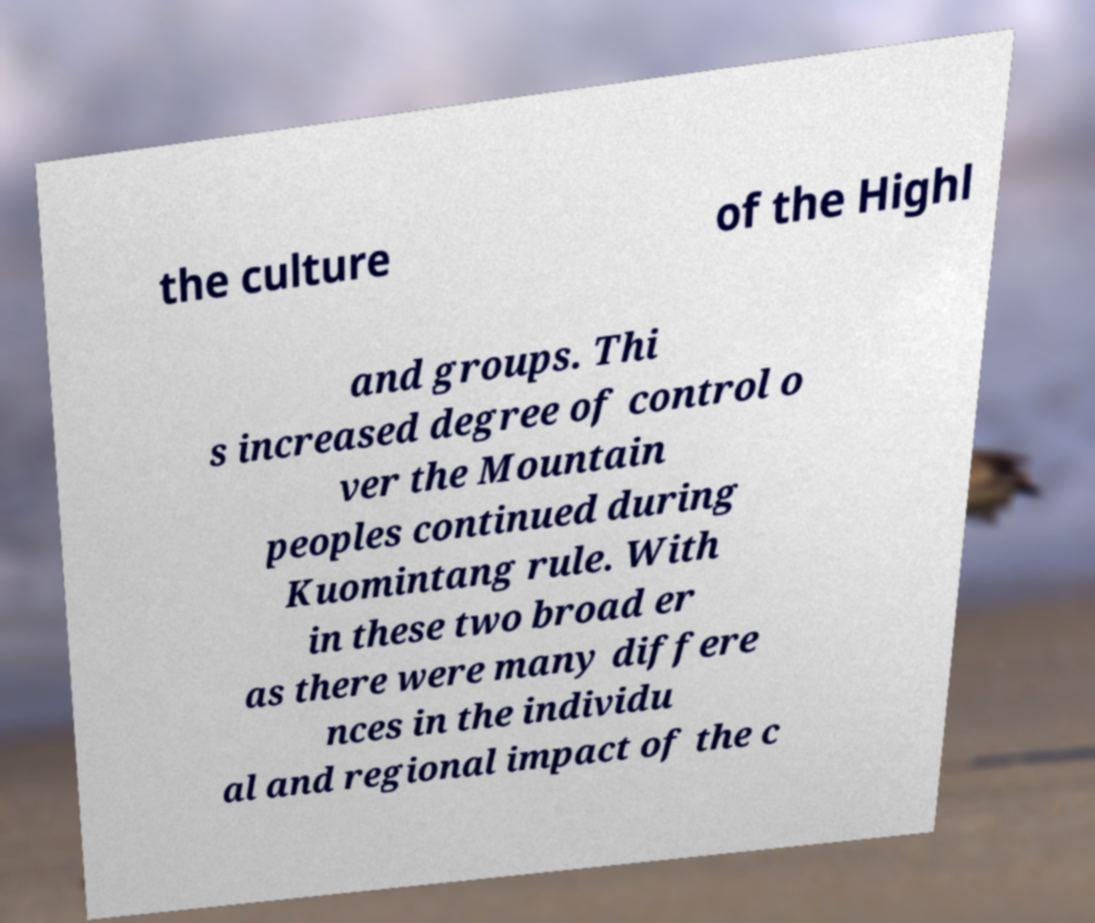Could you assist in decoding the text presented in this image and type it out clearly? the culture of the Highl and groups. Thi s increased degree of control o ver the Mountain peoples continued during Kuomintang rule. With in these two broad er as there were many differe nces in the individu al and regional impact of the c 